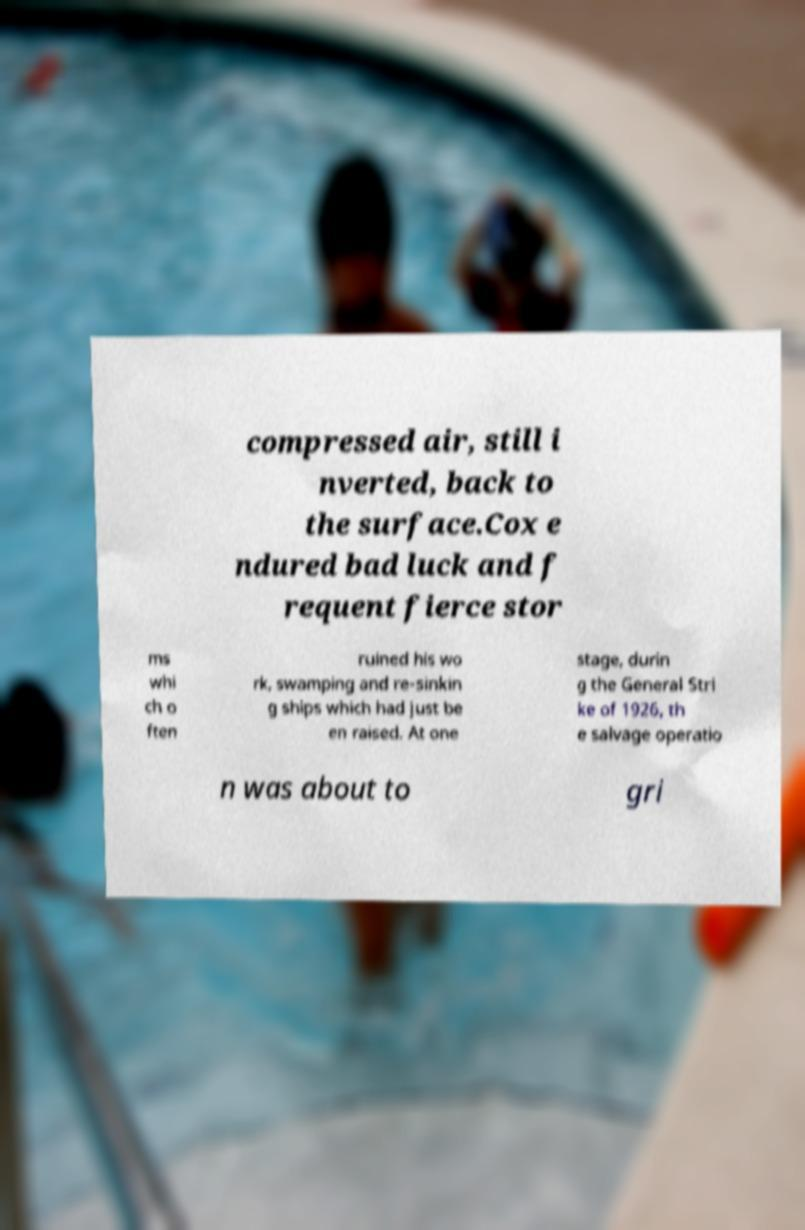Could you assist in decoding the text presented in this image and type it out clearly? compressed air, still i nverted, back to the surface.Cox e ndured bad luck and f requent fierce stor ms whi ch o ften ruined his wo rk, swamping and re-sinkin g ships which had just be en raised. At one stage, durin g the General Stri ke of 1926, th e salvage operatio n was about to gri 